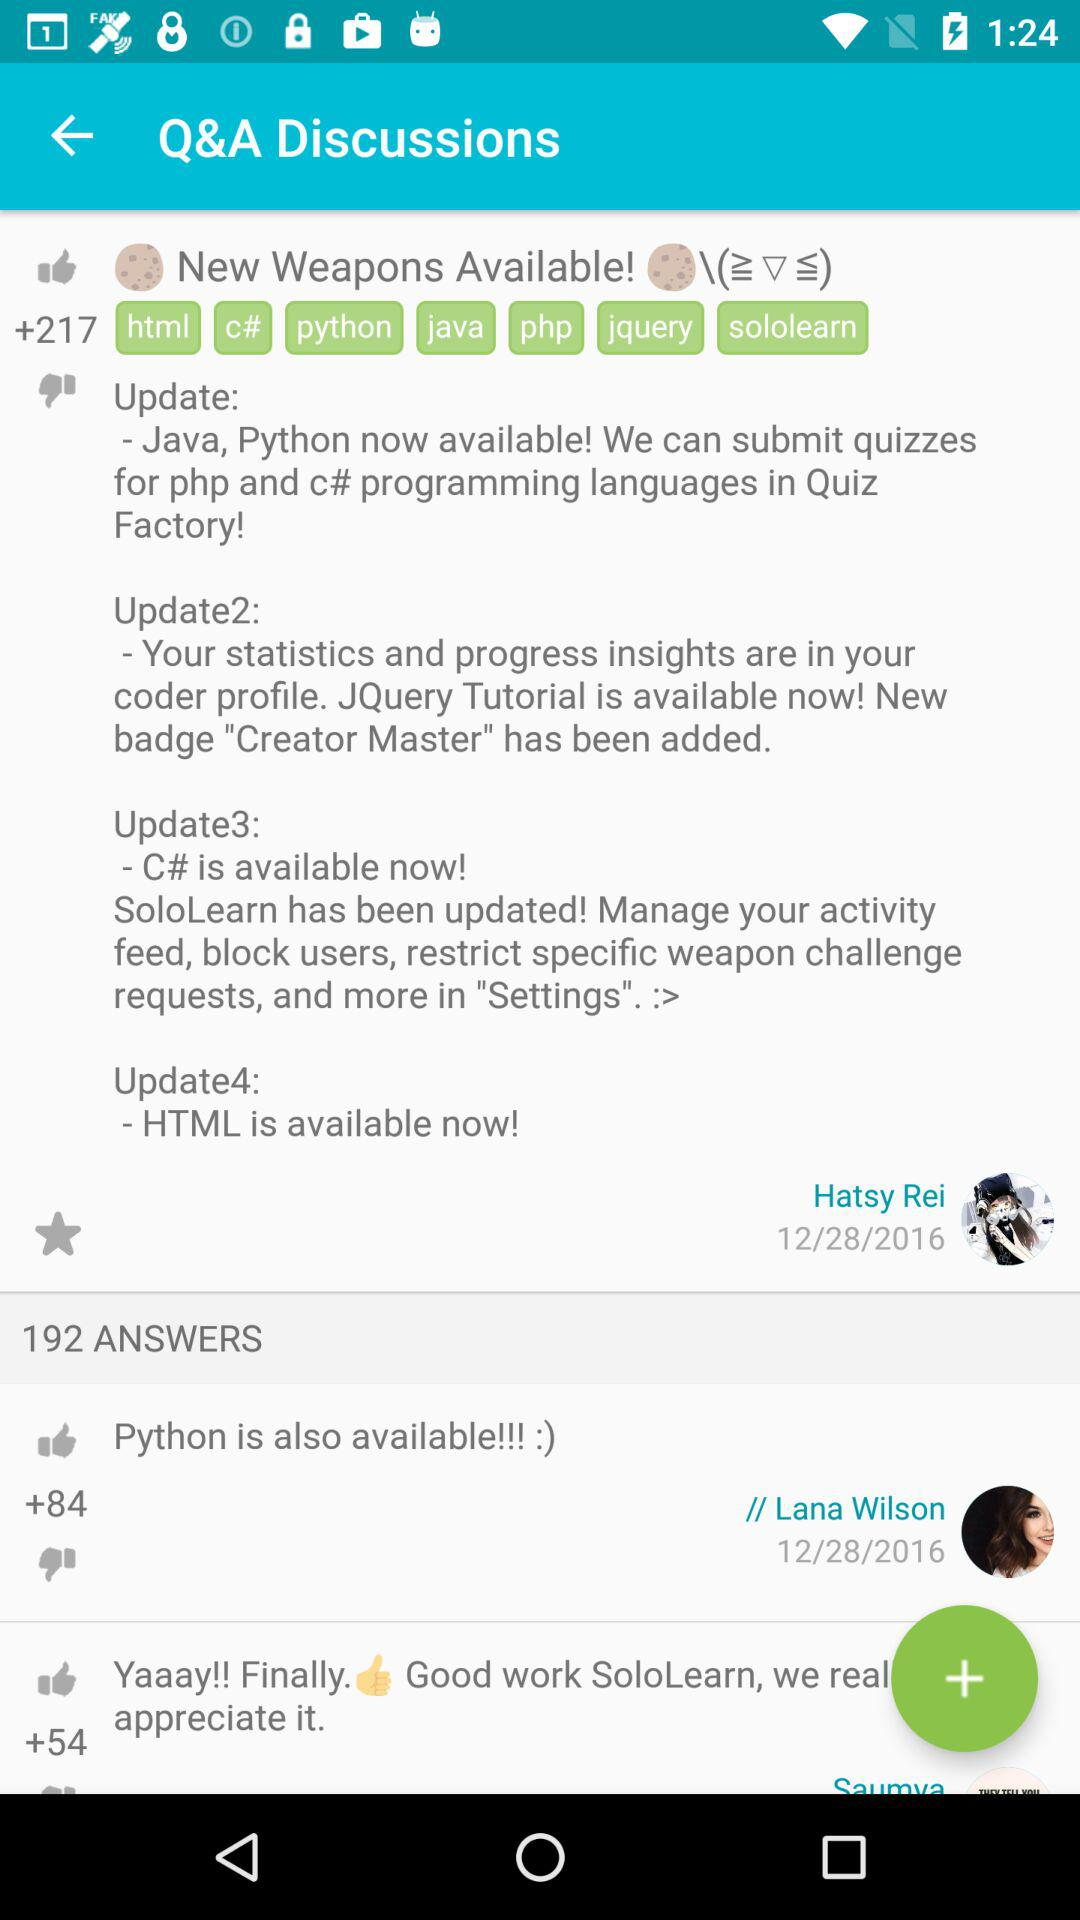What is "Update2"? "Update2" is "Your statistics and progress insights are in your coder profile. JQuery Tutorial is available now! New badge "Creator Master" has been added". 